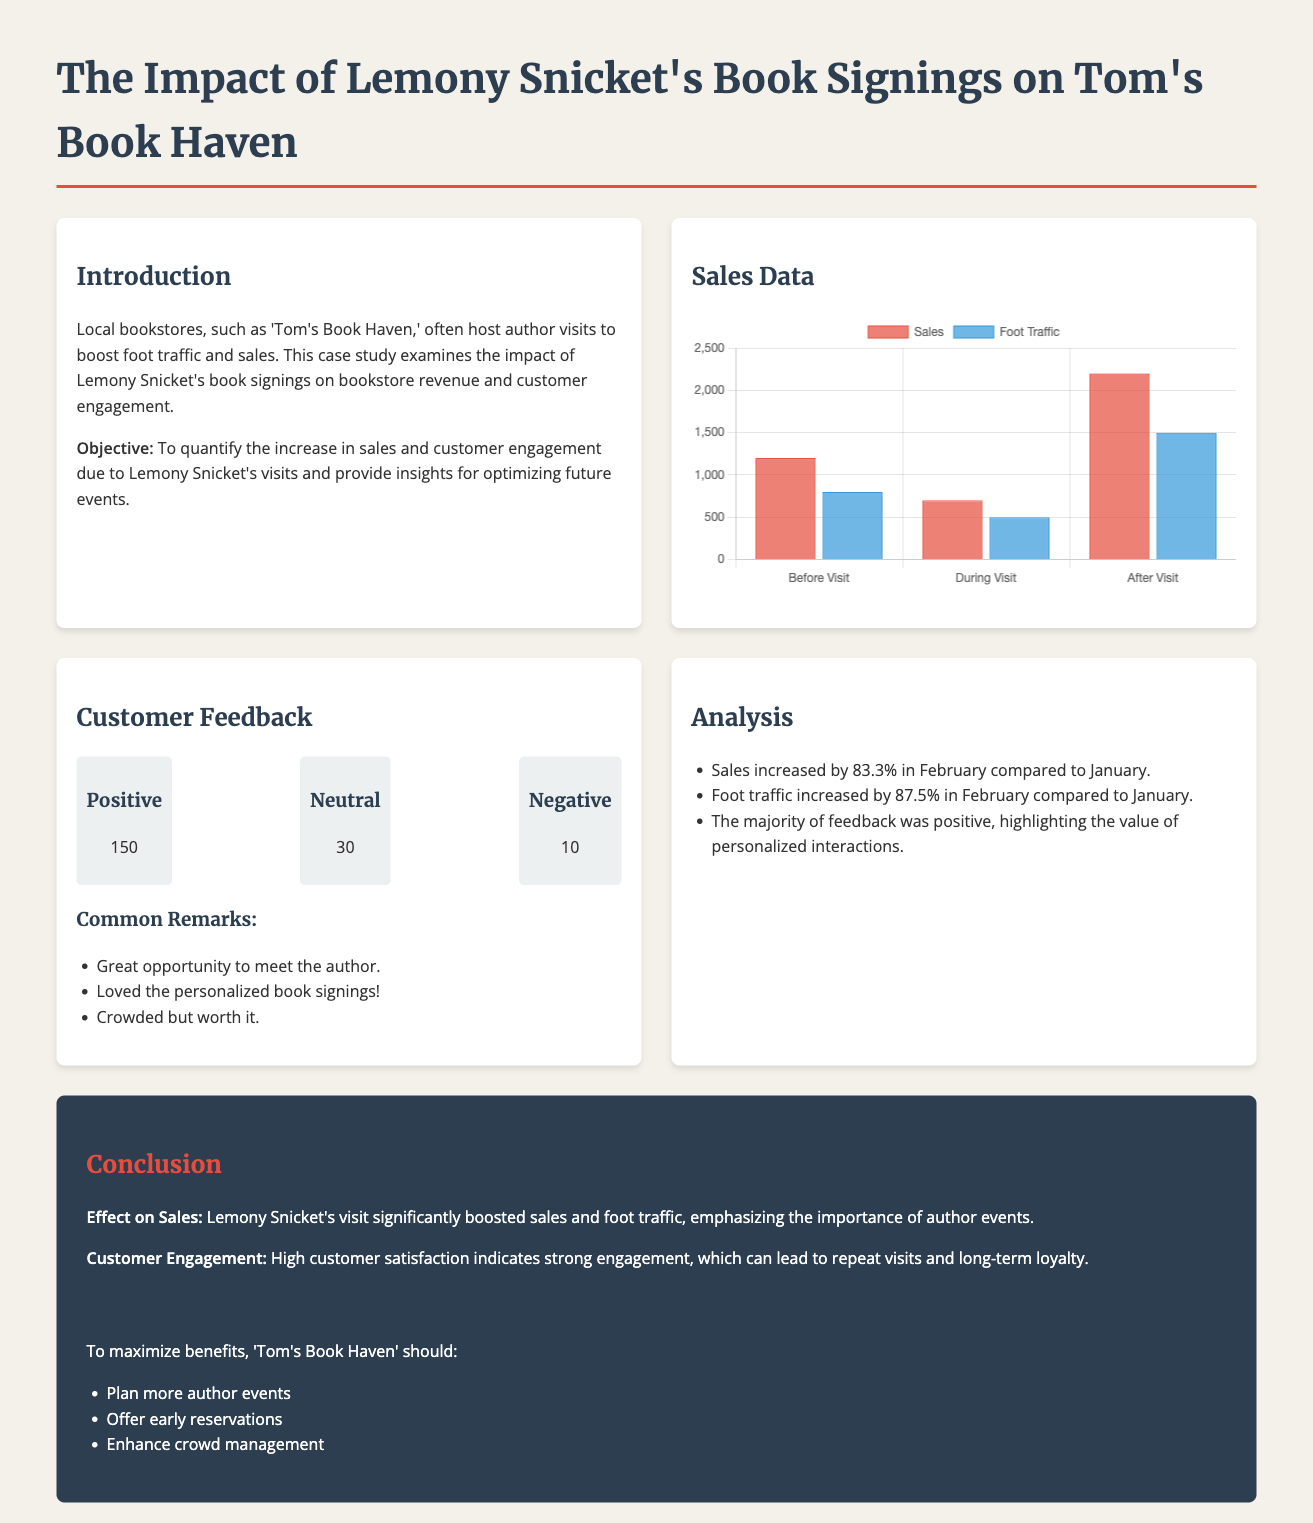what was the increase in sales during February compared to January? The document states that sales increased by 83.3% in February compared to January.
Answer: 83.3% how much foot traffic increased in February compared to January? The document mentions that foot traffic increased by 87.5% in February compared to January.
Answer: 87.5% how many positive feedbacks were received? The feedback section indicates that 150 positive feedbacks were received.
Answer: 150 what was the sales figure before Lemony Snicket's visit? According to the sales data, the sales figure before the visit was 1200.
Answer: 1200 what are the common remarks from customer feedback? The document lists common remarks, which include "Great opportunity to meet the author."
Answer: "Great opportunity to meet the author." what is one recommendation for maximizing the benefits of author events? The conclusion section includes the recommendation to "Plan more author events."
Answer: Plan more author events how many neutral feedbacks were received? The document specifies that 30 neutral feedbacks were logged.
Answer: 30 what is the total number of negative feedbacks? The feedback section indicates that there were 10 negative feedbacks.
Answer: 10 